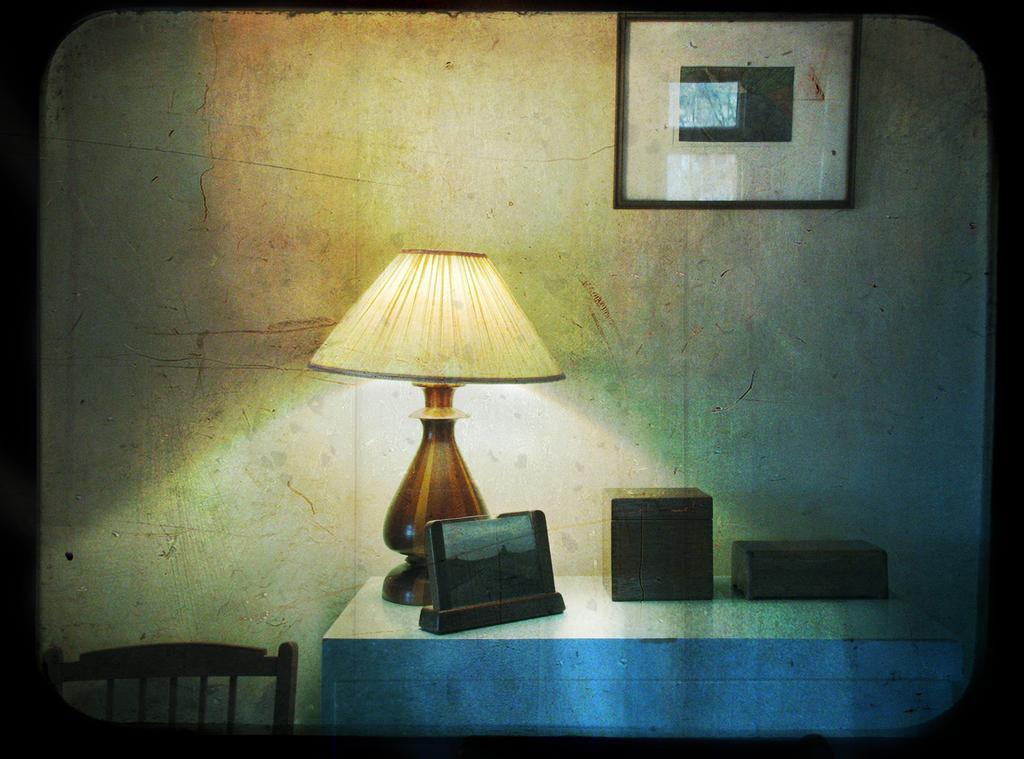Could you give a brief overview of what you see in this image? In the image we can see there is a table on which there is a table lamp and on the wall there is a photo frame. 